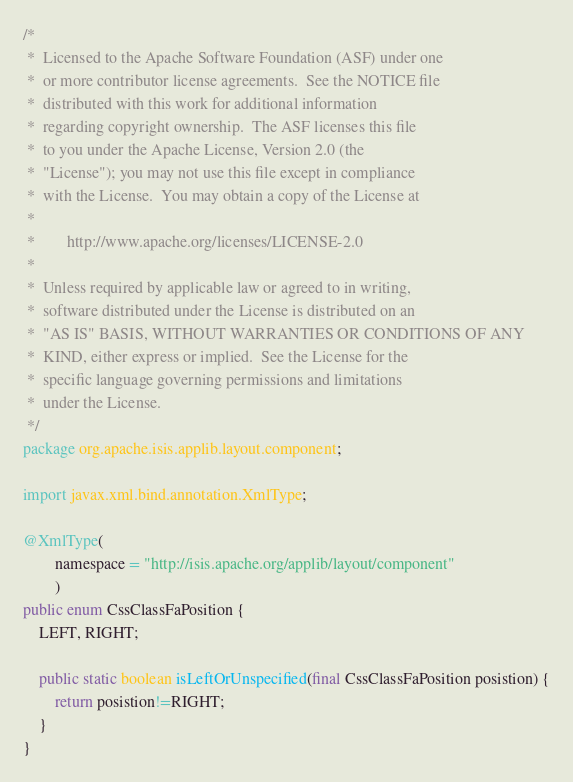Convert code to text. <code><loc_0><loc_0><loc_500><loc_500><_Java_>/*
 *  Licensed to the Apache Software Foundation (ASF) under one
 *  or more contributor license agreements.  See the NOTICE file
 *  distributed with this work for additional information
 *  regarding copyright ownership.  The ASF licenses this file
 *  to you under the Apache License, Version 2.0 (the
 *  "License"); you may not use this file except in compliance
 *  with the License.  You may obtain a copy of the License at
 *
 *        http://www.apache.org/licenses/LICENSE-2.0
 *
 *  Unless required by applicable law or agreed to in writing,
 *  software distributed under the License is distributed on an
 *  "AS IS" BASIS, WITHOUT WARRANTIES OR CONDITIONS OF ANY
 *  KIND, either express or implied.  See the License for the
 *  specific language governing permissions and limitations
 *  under the License.
 */
package org.apache.isis.applib.layout.component;

import javax.xml.bind.annotation.XmlType;

@XmlType(
        namespace = "http://isis.apache.org/applib/layout/component"
        )
public enum CssClassFaPosition {
    LEFT, RIGHT;

    public static boolean isLeftOrUnspecified(final CssClassFaPosition posistion) {
        return posistion!=RIGHT;
    }
}
</code> 